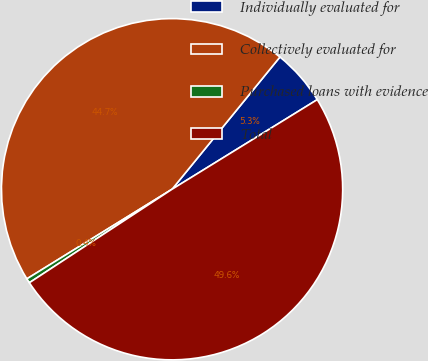Convert chart. <chart><loc_0><loc_0><loc_500><loc_500><pie_chart><fcel>Individually evaluated for<fcel>Collectively evaluated for<fcel>Purchased loans with evidence<fcel>Total<nl><fcel>5.31%<fcel>44.69%<fcel>0.43%<fcel>49.57%<nl></chart> 